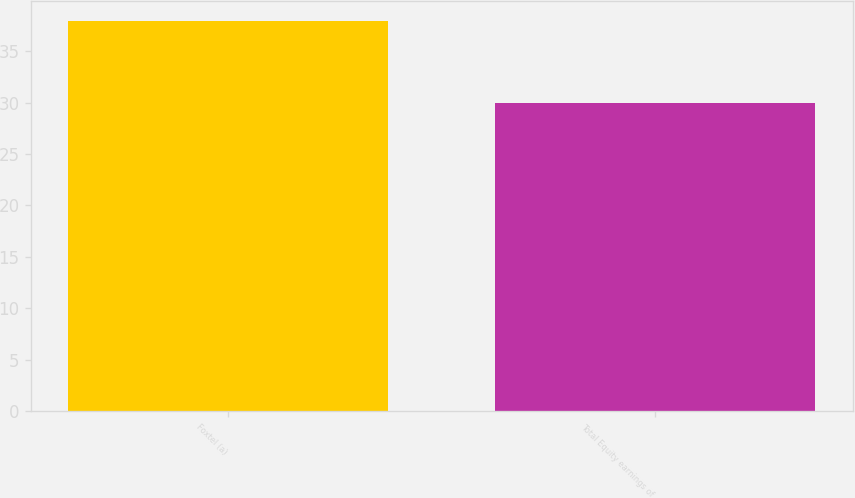Convert chart. <chart><loc_0><loc_0><loc_500><loc_500><bar_chart><fcel>Foxtel (a)<fcel>Total Equity earnings of<nl><fcel>38<fcel>30<nl></chart> 